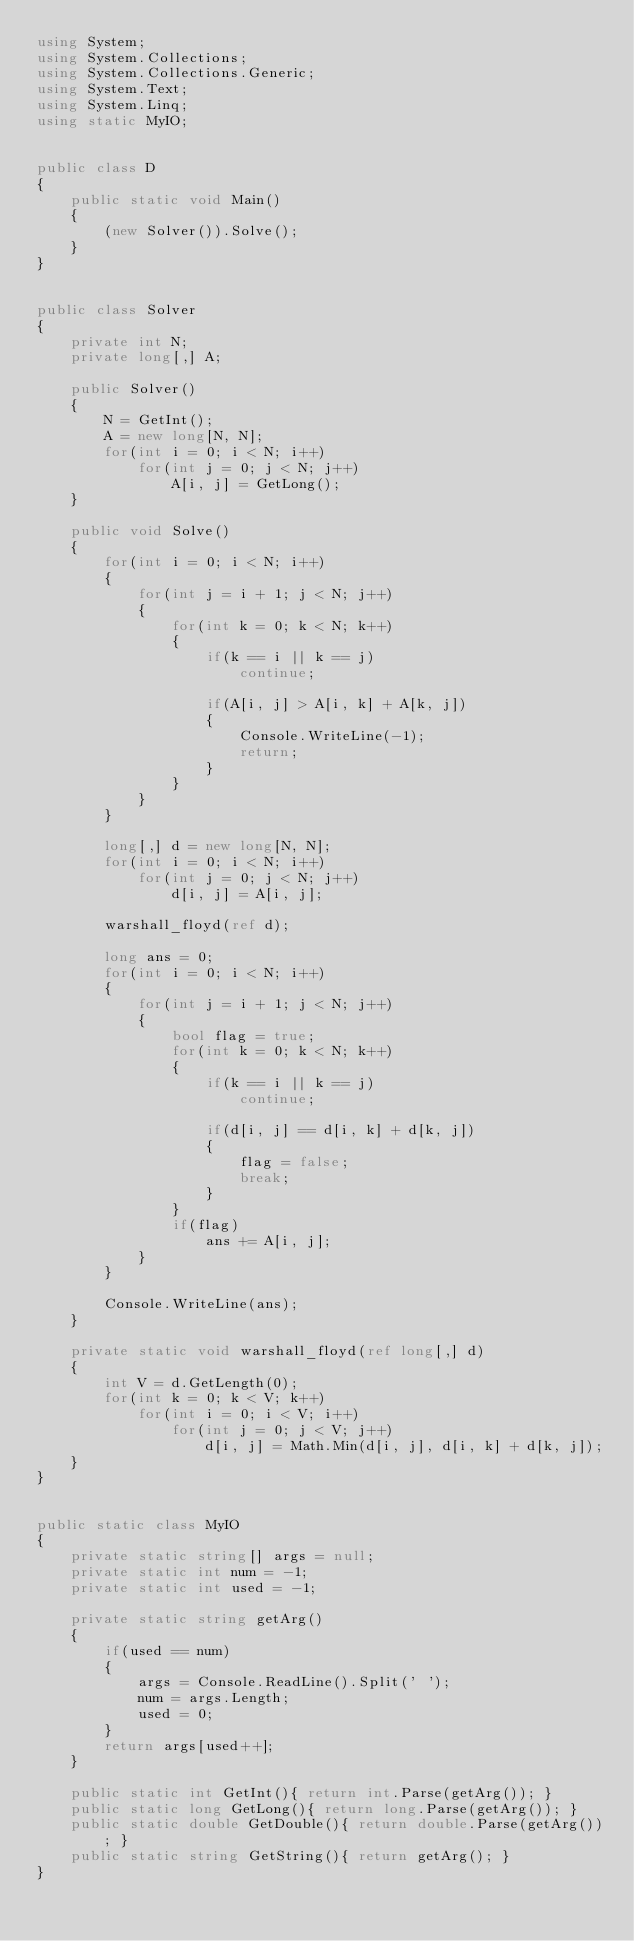Convert code to text. <code><loc_0><loc_0><loc_500><loc_500><_C#_>using System;
using System.Collections;
using System.Collections.Generic;
using System.Text;
using System.Linq;
using static MyIO;


public class D
{
	public static void Main()
	{
		(new Solver()).Solve();
	}
}


public class Solver
{
	private int N;
	private long[,] A;

	public Solver()
	{
		N = GetInt();
		A = new long[N, N];
		for(int i = 0; i < N; i++)
			for(int j = 0; j < N; j++)
				A[i, j] = GetLong();
	}

	public void Solve()
	{
		for(int i = 0; i < N; i++)
		{
			for(int j = i + 1; j < N; j++)
			{
				for(int k = 0; k < N; k++)
				{
					if(k == i || k == j)
						continue;
					
					if(A[i, j] > A[i, k] + A[k, j])
					{
						Console.WriteLine(-1);
						return;
					}
				}
			}
		}

		long[,] d = new long[N, N];
		for(int i = 0; i < N; i++)
			for(int j = 0; j < N; j++)
				d[i, j] = A[i, j];

		warshall_floyd(ref d);

		long ans = 0;
		for(int i = 0; i < N; i++)
		{
			for(int j = i + 1; j < N; j++)
			{
				bool flag = true;
				for(int k = 0; k < N; k++)
				{
					if(k == i || k == j)
						continue;
					
					if(d[i, j] == d[i, k] + d[k, j])
					{
						flag = false;
						break;
					}
				}
				if(flag)
					ans += A[i, j];
			}
		}

		Console.WriteLine(ans);
	}

	private static void warshall_floyd(ref long[,] d)
	{
		int V = d.GetLength(0);
		for(int k = 0; k < V; k++)
			for(int i = 0; i < V; i++)
				for(int j = 0; j < V; j++)
					d[i, j] = Math.Min(d[i, j], d[i, k] + d[k, j]);
	}
}


public static class MyIO
{
	private static string[] args = null;
	private static int num = -1;
	private static int used = -1;

	private static string getArg()
	{
		if(used == num)
		{
			args = Console.ReadLine().Split(' ');
			num = args.Length;
			used = 0;
		}
		return args[used++];
	}

	public static int GetInt(){ return int.Parse(getArg()); }
	public static long GetLong(){ return long.Parse(getArg()); }
	public static double GetDouble(){ return double.Parse(getArg()); }
	public static string GetString(){ return getArg(); }
}



</code> 